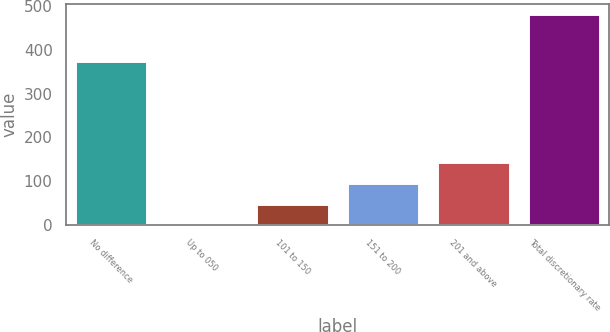Convert chart to OTSL. <chart><loc_0><loc_0><loc_500><loc_500><bar_chart><fcel>No difference<fcel>Up to 050<fcel>101 to 150<fcel>151 to 200<fcel>201 and above<fcel>Total discretionary rate<nl><fcel>374.8<fcel>0.2<fcel>48.32<fcel>96.44<fcel>144.56<fcel>481.4<nl></chart> 